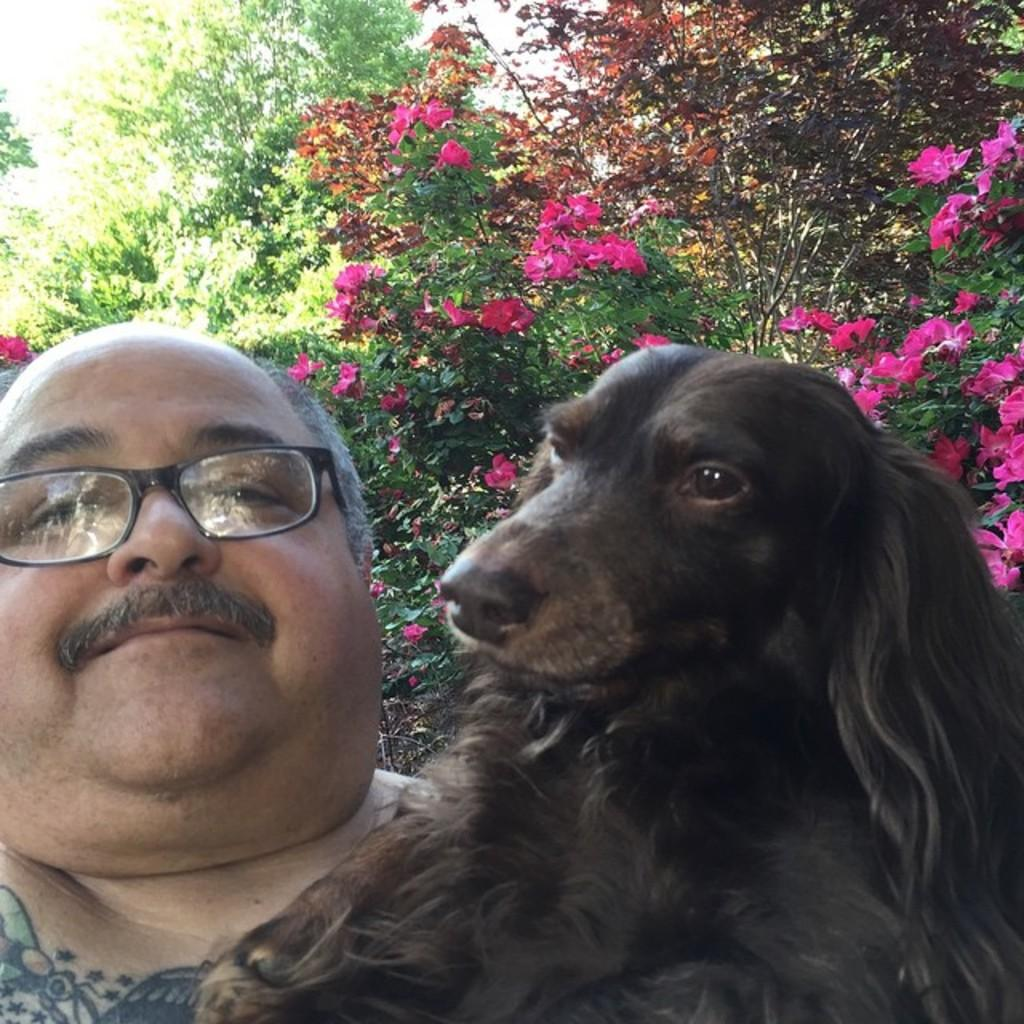What is the man in the image holding? The man is holding a dog in the image. Can you describe the dog? The dog is black. What can be seen in the background of the image? There are plants in the background of the image. What color are the flowers on the plants? The flowers on the plants are pink. What holiday advice does the man in the image give to the dog? There is no indication in the image that the man is giving any holiday advice to the dog. 